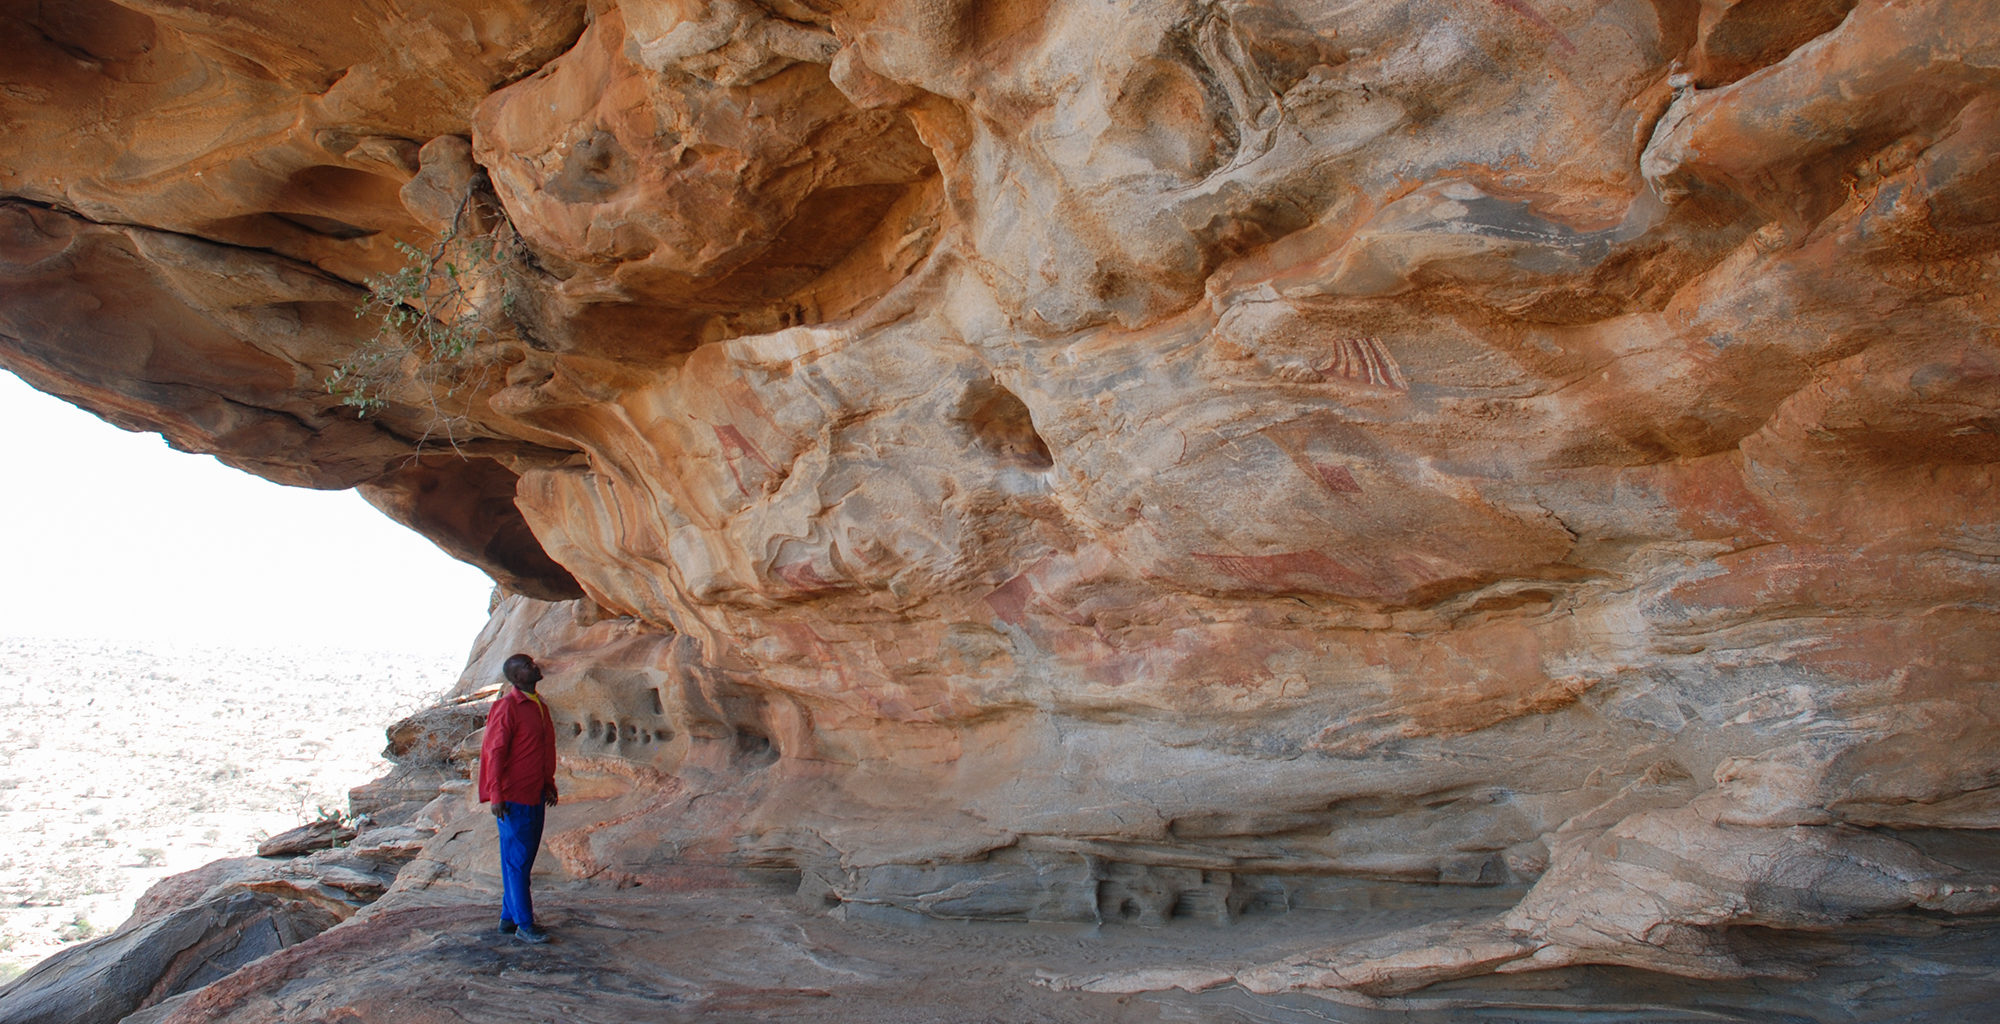Describe a scenario where this place serves as a pivotal location in an epic adventure novel. In an epic adventure novel, this ancient rock art site could be the hidden location of a legendary artifact, sought by adventurers from across the globe. The protagonist, a skilled archaeologist with a deep respect for history, uncovers ancient scrolls hinting at the artifact's location buried beneath the cave's detailed paintings. As they embark on their journey, they face fierce rivals, treacherous landscapes, and the timeless enigma of the Laas Geel. The site, with its vast desert backdrop and intricate rock art, becomes the setting for a final, climactic confrontation, where the secrets of ancient civilizations intertwine with the protagonist's quest for knowledge and legacy. 